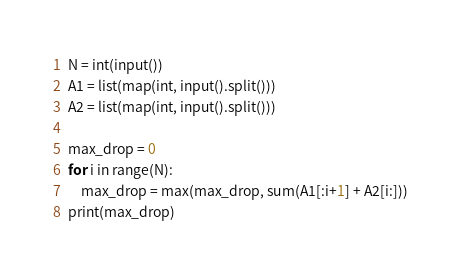Convert code to text. <code><loc_0><loc_0><loc_500><loc_500><_Python_>N = int(input())
A1 = list(map(int, input().split()))
A2 = list(map(int, input().split()))

max_drop = 0
for i in range(N):
    max_drop = max(max_drop, sum(A1[:i+1] + A2[i:]))
print(max_drop)</code> 